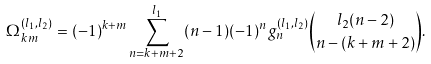Convert formula to latex. <formula><loc_0><loc_0><loc_500><loc_500>\Omega _ { k m } ^ { ( l _ { 1 } , l _ { 2 } ) } = ( - 1 ) ^ { k + m } \sum _ { n = k + m + 2 } ^ { l _ { 1 } } ( n - 1 ) ( - 1 ) ^ { n } g _ { n } ^ { ( l _ { 1 } , l _ { 2 } ) } { l _ { 2 } ( n - 2 ) \choose n - ( k + m + 2 ) } .</formula> 